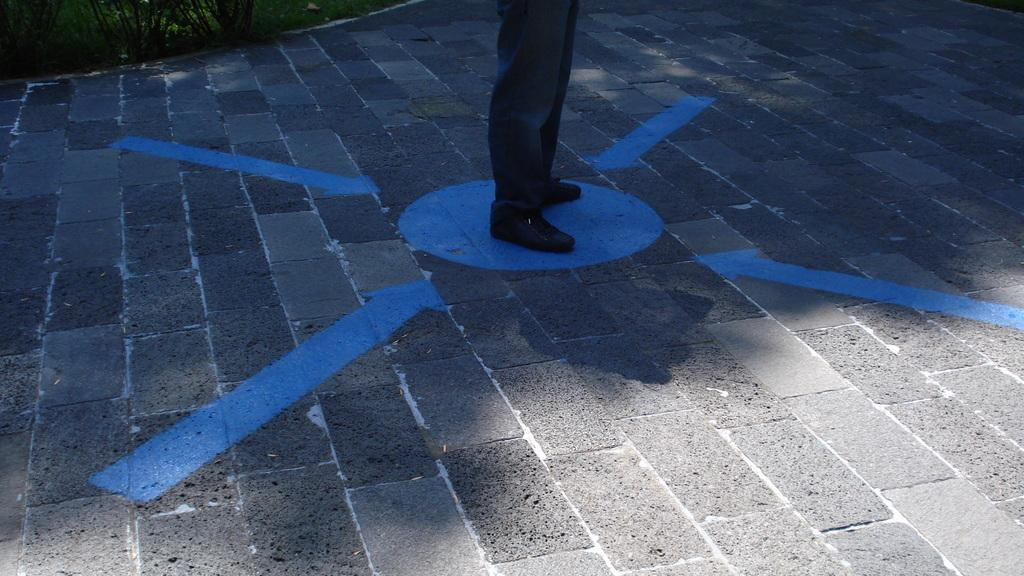What type of natural elements are present in the image? There are plants and grass in the image. What can be seen on the road in the image? There are blue color arrows and a circle on the road in the image. What part of a person is visible on the circle? A person's legs with black shoes are on the circle. What type of smoke can be seen coming from the plants in the image? There is no smoke present in the image; it features plants and grass without any indication of smoke. 